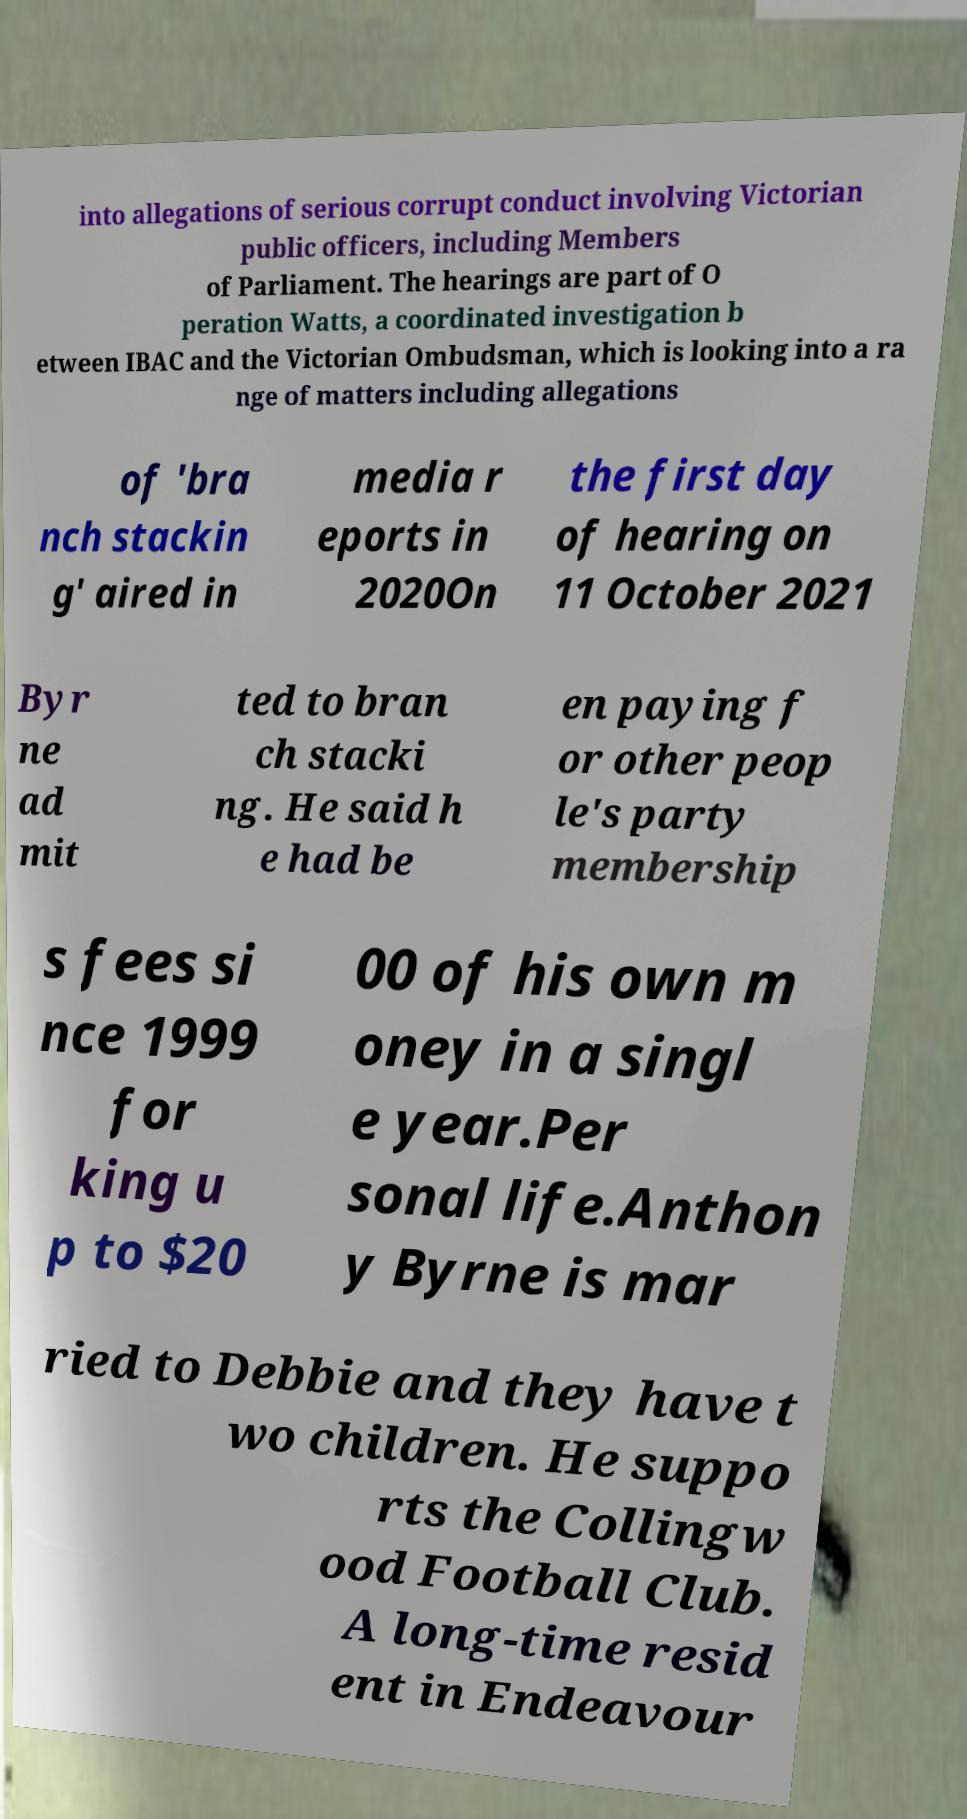For documentation purposes, I need the text within this image transcribed. Could you provide that? into allegations of serious corrupt conduct involving Victorian public officers, including Members of Parliament. The hearings are part of O peration Watts, a coordinated investigation b etween IBAC and the Victorian Ombudsman, which is looking into a ra nge of matters including allegations of 'bra nch stackin g' aired in media r eports in 2020On the first day of hearing on 11 October 2021 Byr ne ad mit ted to bran ch stacki ng. He said h e had be en paying f or other peop le's party membership s fees si nce 1999 for king u p to $20 00 of his own m oney in a singl e year.Per sonal life.Anthon y Byrne is mar ried to Debbie and they have t wo children. He suppo rts the Collingw ood Football Club. A long-time resid ent in Endeavour 